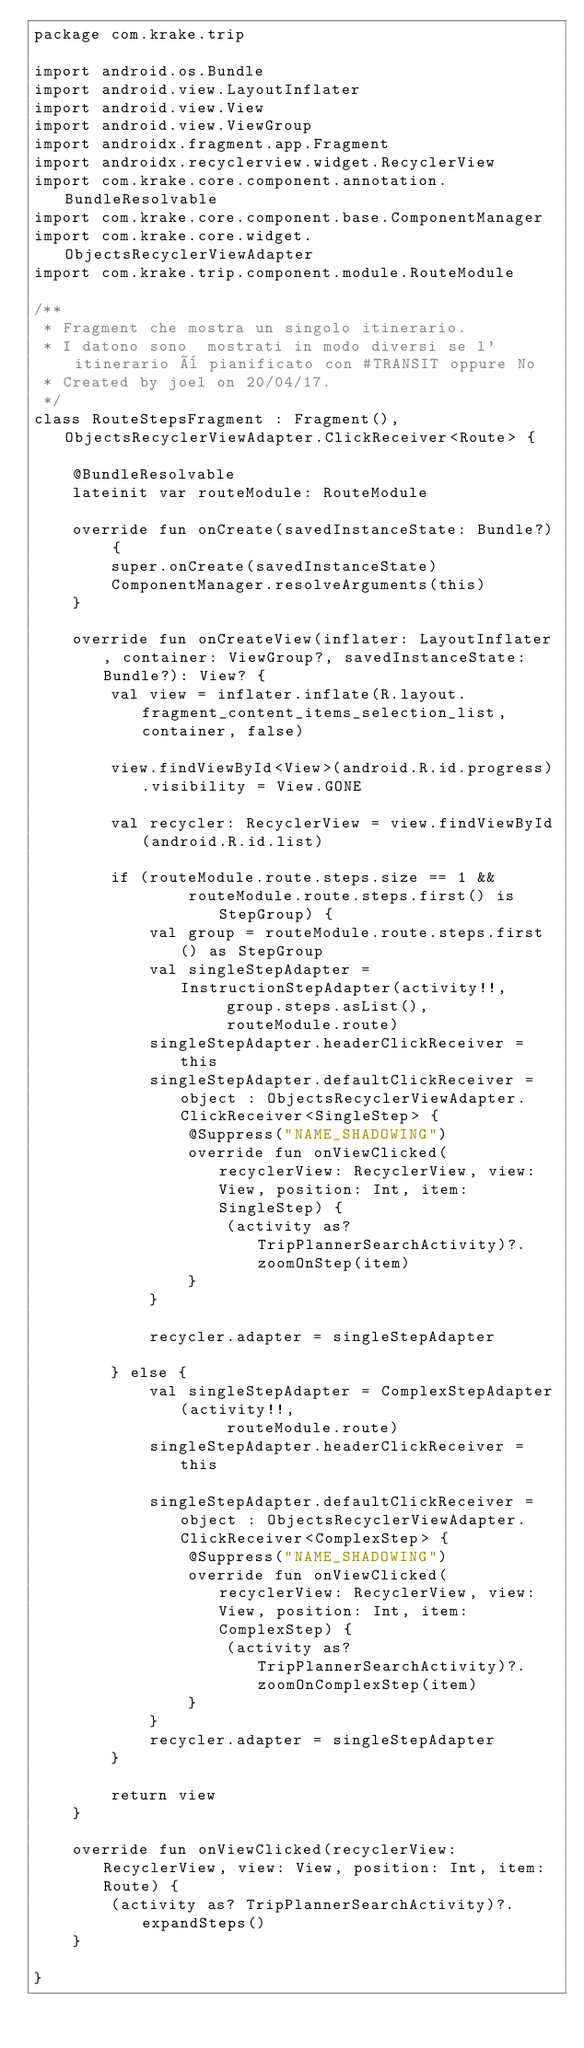Convert code to text. <code><loc_0><loc_0><loc_500><loc_500><_Kotlin_>package com.krake.trip

import android.os.Bundle
import android.view.LayoutInflater
import android.view.View
import android.view.ViewGroup
import androidx.fragment.app.Fragment
import androidx.recyclerview.widget.RecyclerView
import com.krake.core.component.annotation.BundleResolvable
import com.krake.core.component.base.ComponentManager
import com.krake.core.widget.ObjectsRecyclerViewAdapter
import com.krake.trip.component.module.RouteModule

/**
 * Fragment che mostra un singolo itinerario.
 * I datono sono  mostrati in modo diversi se l'itinerario è pianificato con #TRANSIT oppure No
 * Created by joel on 20/04/17.
 */
class RouteStepsFragment : Fragment(), ObjectsRecyclerViewAdapter.ClickReceiver<Route> {

    @BundleResolvable
    lateinit var routeModule: RouteModule

    override fun onCreate(savedInstanceState: Bundle?) {
        super.onCreate(savedInstanceState)
        ComponentManager.resolveArguments(this)
    }

    override fun onCreateView(inflater: LayoutInflater, container: ViewGroup?, savedInstanceState: Bundle?): View? {
        val view = inflater.inflate(R.layout.fragment_content_items_selection_list, container, false)

        view.findViewById<View>(android.R.id.progress).visibility = View.GONE

        val recycler: RecyclerView = view.findViewById(android.R.id.list)

        if (routeModule.route.steps.size == 1 &&
                routeModule.route.steps.first() is StepGroup) {
            val group = routeModule.route.steps.first() as StepGroup
            val singleStepAdapter = InstructionStepAdapter(activity!!,
                    group.steps.asList(),
                    routeModule.route)
            singleStepAdapter.headerClickReceiver = this
            singleStepAdapter.defaultClickReceiver = object : ObjectsRecyclerViewAdapter.ClickReceiver<SingleStep> {
                @Suppress("NAME_SHADOWING")
                override fun onViewClicked(recyclerView: RecyclerView, view: View, position: Int, item: SingleStep) {
                    (activity as? TripPlannerSearchActivity)?.zoomOnStep(item)
                }
            }

            recycler.adapter = singleStepAdapter

        } else {
            val singleStepAdapter = ComplexStepAdapter(activity!!,
                    routeModule.route)
            singleStepAdapter.headerClickReceiver = this

            singleStepAdapter.defaultClickReceiver = object : ObjectsRecyclerViewAdapter.ClickReceiver<ComplexStep> {
                @Suppress("NAME_SHADOWING")
                override fun onViewClicked(recyclerView: RecyclerView, view: View, position: Int, item: ComplexStep) {
                    (activity as? TripPlannerSearchActivity)?.zoomOnComplexStep(item)
                }
            }
            recycler.adapter = singleStepAdapter
        }

        return view
    }

    override fun onViewClicked(recyclerView: RecyclerView, view: View, position: Int, item: Route) {
        (activity as? TripPlannerSearchActivity)?.expandSteps()
    }

}</code> 